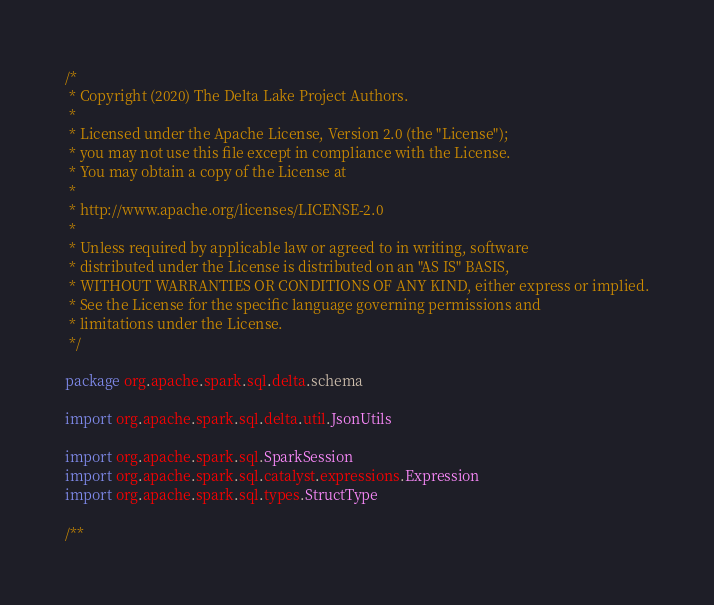Convert code to text. <code><loc_0><loc_0><loc_500><loc_500><_Scala_>/*
 * Copyright (2020) The Delta Lake Project Authors.
 *
 * Licensed under the Apache License, Version 2.0 (the "License");
 * you may not use this file except in compliance with the License.
 * You may obtain a copy of the License at
 *
 * http://www.apache.org/licenses/LICENSE-2.0
 *
 * Unless required by applicable law or agreed to in writing, software
 * distributed under the License is distributed on an "AS IS" BASIS,
 * WITHOUT WARRANTIES OR CONDITIONS OF ANY KIND, either express or implied.
 * See the License for the specific language governing permissions and
 * limitations under the License.
 */

package org.apache.spark.sql.delta.schema

import org.apache.spark.sql.delta.util.JsonUtils

import org.apache.spark.sql.SparkSession
import org.apache.spark.sql.catalyst.expressions.Expression
import org.apache.spark.sql.types.StructType

/**</code> 